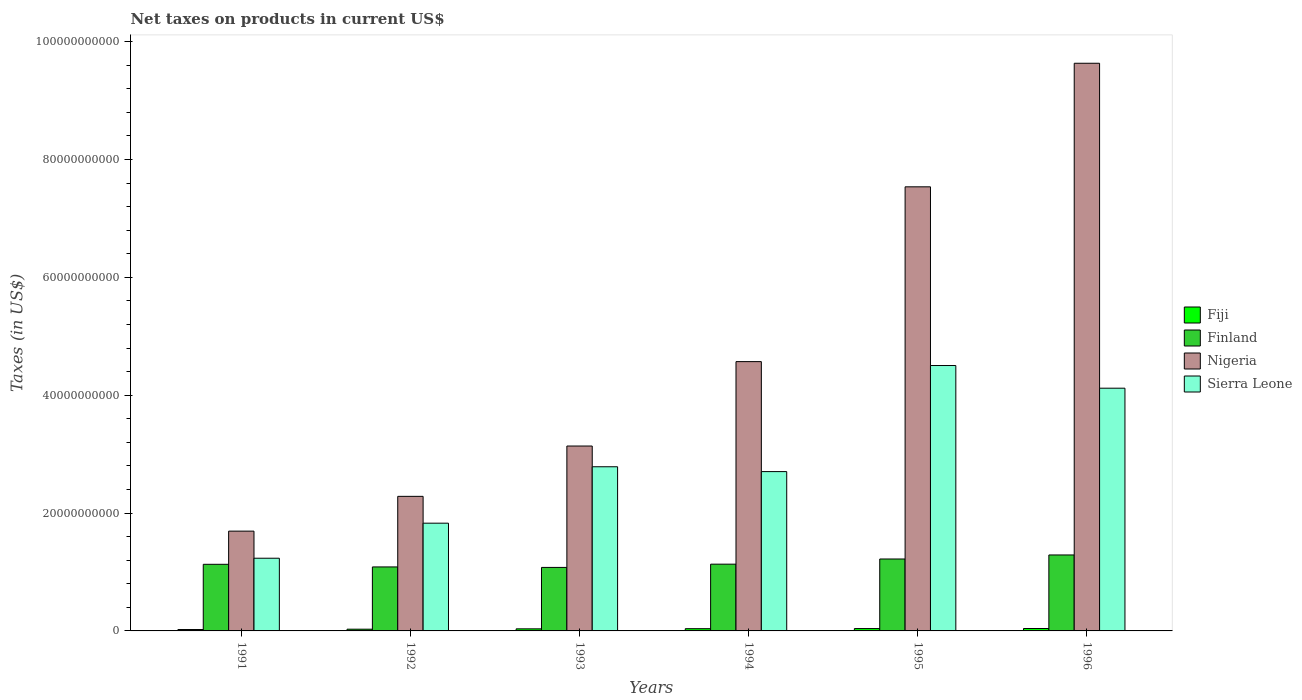Are the number of bars on each tick of the X-axis equal?
Your answer should be very brief. Yes. What is the net taxes on products in Nigeria in 1992?
Keep it short and to the point. 2.28e+1. Across all years, what is the maximum net taxes on products in Fiji?
Your answer should be compact. 4.10e+08. Across all years, what is the minimum net taxes on products in Fiji?
Your response must be concise. 2.37e+08. What is the total net taxes on products in Nigeria in the graph?
Your answer should be very brief. 2.88e+11. What is the difference between the net taxes on products in Nigeria in 1994 and that in 1995?
Offer a terse response. -2.97e+1. What is the difference between the net taxes on products in Nigeria in 1994 and the net taxes on products in Sierra Leone in 1995?
Provide a short and direct response. 6.62e+08. What is the average net taxes on products in Sierra Leone per year?
Keep it short and to the point. 2.86e+1. In the year 1992, what is the difference between the net taxes on products in Finland and net taxes on products in Sierra Leone?
Provide a succinct answer. -7.42e+09. What is the ratio of the net taxes on products in Fiji in 1991 to that in 1993?
Keep it short and to the point. 0.67. Is the difference between the net taxes on products in Finland in 1993 and 1994 greater than the difference between the net taxes on products in Sierra Leone in 1993 and 1994?
Offer a very short reply. No. What is the difference between the highest and the second highest net taxes on products in Finland?
Give a very brief answer. 6.85e+08. What is the difference between the highest and the lowest net taxes on products in Sierra Leone?
Provide a short and direct response. 3.27e+1. What does the 1st bar from the left in 1993 represents?
Keep it short and to the point. Fiji. What does the 3rd bar from the right in 1991 represents?
Offer a terse response. Finland. How many bars are there?
Provide a short and direct response. 24. How many years are there in the graph?
Provide a short and direct response. 6. Does the graph contain any zero values?
Provide a succinct answer. No. Does the graph contain grids?
Offer a very short reply. No. How many legend labels are there?
Provide a short and direct response. 4. How are the legend labels stacked?
Provide a succinct answer. Vertical. What is the title of the graph?
Offer a very short reply. Net taxes on products in current US$. What is the label or title of the Y-axis?
Keep it short and to the point. Taxes (in US$). What is the Taxes (in US$) in Fiji in 1991?
Your response must be concise. 2.37e+08. What is the Taxes (in US$) of Finland in 1991?
Offer a terse response. 1.13e+1. What is the Taxes (in US$) in Nigeria in 1991?
Your response must be concise. 1.69e+1. What is the Taxes (in US$) in Sierra Leone in 1991?
Provide a succinct answer. 1.23e+1. What is the Taxes (in US$) of Fiji in 1992?
Your answer should be very brief. 2.92e+08. What is the Taxes (in US$) in Finland in 1992?
Your response must be concise. 1.09e+1. What is the Taxes (in US$) in Nigeria in 1992?
Ensure brevity in your answer.  2.28e+1. What is the Taxes (in US$) of Sierra Leone in 1992?
Your answer should be very brief. 1.83e+1. What is the Taxes (in US$) of Fiji in 1993?
Your response must be concise. 3.52e+08. What is the Taxes (in US$) of Finland in 1993?
Ensure brevity in your answer.  1.08e+1. What is the Taxes (in US$) in Nigeria in 1993?
Offer a terse response. 3.14e+1. What is the Taxes (in US$) of Sierra Leone in 1993?
Offer a terse response. 2.79e+1. What is the Taxes (in US$) in Fiji in 1994?
Your answer should be very brief. 3.79e+08. What is the Taxes (in US$) in Finland in 1994?
Make the answer very short. 1.13e+1. What is the Taxes (in US$) of Nigeria in 1994?
Offer a terse response. 4.57e+1. What is the Taxes (in US$) in Sierra Leone in 1994?
Your response must be concise. 2.70e+1. What is the Taxes (in US$) in Fiji in 1995?
Your answer should be very brief. 3.98e+08. What is the Taxes (in US$) of Finland in 1995?
Your answer should be compact. 1.22e+1. What is the Taxes (in US$) of Nigeria in 1995?
Give a very brief answer. 7.54e+1. What is the Taxes (in US$) of Sierra Leone in 1995?
Give a very brief answer. 4.50e+1. What is the Taxes (in US$) in Fiji in 1996?
Give a very brief answer. 4.10e+08. What is the Taxes (in US$) of Finland in 1996?
Provide a succinct answer. 1.29e+1. What is the Taxes (in US$) of Nigeria in 1996?
Your answer should be very brief. 9.63e+1. What is the Taxes (in US$) of Sierra Leone in 1996?
Your answer should be compact. 4.12e+1. Across all years, what is the maximum Taxes (in US$) in Fiji?
Your answer should be compact. 4.10e+08. Across all years, what is the maximum Taxes (in US$) in Finland?
Provide a short and direct response. 1.29e+1. Across all years, what is the maximum Taxes (in US$) of Nigeria?
Make the answer very short. 9.63e+1. Across all years, what is the maximum Taxes (in US$) of Sierra Leone?
Ensure brevity in your answer.  4.50e+1. Across all years, what is the minimum Taxes (in US$) in Fiji?
Offer a very short reply. 2.37e+08. Across all years, what is the minimum Taxes (in US$) of Finland?
Provide a short and direct response. 1.08e+1. Across all years, what is the minimum Taxes (in US$) in Nigeria?
Ensure brevity in your answer.  1.69e+1. Across all years, what is the minimum Taxes (in US$) in Sierra Leone?
Offer a terse response. 1.23e+1. What is the total Taxes (in US$) of Fiji in the graph?
Give a very brief answer. 2.07e+09. What is the total Taxes (in US$) in Finland in the graph?
Provide a succinct answer. 6.94e+1. What is the total Taxes (in US$) of Nigeria in the graph?
Offer a very short reply. 2.88e+11. What is the total Taxes (in US$) of Sierra Leone in the graph?
Offer a very short reply. 1.72e+11. What is the difference between the Taxes (in US$) of Fiji in 1991 and that in 1992?
Your answer should be very brief. -5.58e+07. What is the difference between the Taxes (in US$) in Finland in 1991 and that in 1992?
Offer a very short reply. 4.46e+08. What is the difference between the Taxes (in US$) in Nigeria in 1991 and that in 1992?
Your response must be concise. -5.90e+09. What is the difference between the Taxes (in US$) of Sierra Leone in 1991 and that in 1992?
Provide a succinct answer. -5.95e+09. What is the difference between the Taxes (in US$) of Fiji in 1991 and that in 1993?
Your answer should be very brief. -1.16e+08. What is the difference between the Taxes (in US$) in Finland in 1991 and that in 1993?
Give a very brief answer. 5.28e+08. What is the difference between the Taxes (in US$) in Nigeria in 1991 and that in 1993?
Offer a very short reply. -1.44e+1. What is the difference between the Taxes (in US$) of Sierra Leone in 1991 and that in 1993?
Provide a succinct answer. -1.55e+1. What is the difference between the Taxes (in US$) in Fiji in 1991 and that in 1994?
Your response must be concise. -1.42e+08. What is the difference between the Taxes (in US$) of Finland in 1991 and that in 1994?
Your response must be concise. -2.30e+07. What is the difference between the Taxes (in US$) in Nigeria in 1991 and that in 1994?
Give a very brief answer. -2.88e+1. What is the difference between the Taxes (in US$) in Sierra Leone in 1991 and that in 1994?
Your answer should be compact. -1.47e+1. What is the difference between the Taxes (in US$) of Fiji in 1991 and that in 1995?
Make the answer very short. -1.61e+08. What is the difference between the Taxes (in US$) of Finland in 1991 and that in 1995?
Your answer should be compact. -9.01e+08. What is the difference between the Taxes (in US$) of Nigeria in 1991 and that in 1995?
Offer a very short reply. -5.84e+1. What is the difference between the Taxes (in US$) of Sierra Leone in 1991 and that in 1995?
Offer a very short reply. -3.27e+1. What is the difference between the Taxes (in US$) of Fiji in 1991 and that in 1996?
Give a very brief answer. -1.73e+08. What is the difference between the Taxes (in US$) in Finland in 1991 and that in 1996?
Your answer should be compact. -1.59e+09. What is the difference between the Taxes (in US$) of Nigeria in 1991 and that in 1996?
Make the answer very short. -7.94e+1. What is the difference between the Taxes (in US$) in Sierra Leone in 1991 and that in 1996?
Offer a terse response. -2.88e+1. What is the difference between the Taxes (in US$) of Fiji in 1992 and that in 1993?
Offer a very short reply. -5.97e+07. What is the difference between the Taxes (in US$) in Finland in 1992 and that in 1993?
Your answer should be very brief. 8.20e+07. What is the difference between the Taxes (in US$) of Nigeria in 1992 and that in 1993?
Offer a terse response. -8.54e+09. What is the difference between the Taxes (in US$) of Sierra Leone in 1992 and that in 1993?
Make the answer very short. -9.57e+09. What is the difference between the Taxes (in US$) in Fiji in 1992 and that in 1994?
Ensure brevity in your answer.  -8.65e+07. What is the difference between the Taxes (in US$) of Finland in 1992 and that in 1994?
Your answer should be compact. -4.69e+08. What is the difference between the Taxes (in US$) of Nigeria in 1992 and that in 1994?
Your answer should be compact. -2.29e+1. What is the difference between the Taxes (in US$) in Sierra Leone in 1992 and that in 1994?
Provide a succinct answer. -8.75e+09. What is the difference between the Taxes (in US$) in Fiji in 1992 and that in 1995?
Your response must be concise. -1.05e+08. What is the difference between the Taxes (in US$) in Finland in 1992 and that in 1995?
Provide a short and direct response. -1.35e+09. What is the difference between the Taxes (in US$) of Nigeria in 1992 and that in 1995?
Your answer should be compact. -5.25e+1. What is the difference between the Taxes (in US$) of Sierra Leone in 1992 and that in 1995?
Your response must be concise. -2.68e+1. What is the difference between the Taxes (in US$) in Fiji in 1992 and that in 1996?
Provide a succinct answer. -1.17e+08. What is the difference between the Taxes (in US$) of Finland in 1992 and that in 1996?
Your answer should be very brief. -2.03e+09. What is the difference between the Taxes (in US$) of Nigeria in 1992 and that in 1996?
Keep it short and to the point. -7.35e+1. What is the difference between the Taxes (in US$) of Sierra Leone in 1992 and that in 1996?
Your answer should be very brief. -2.29e+1. What is the difference between the Taxes (in US$) of Fiji in 1993 and that in 1994?
Your answer should be very brief. -2.68e+07. What is the difference between the Taxes (in US$) of Finland in 1993 and that in 1994?
Offer a terse response. -5.51e+08. What is the difference between the Taxes (in US$) of Nigeria in 1993 and that in 1994?
Give a very brief answer. -1.43e+1. What is the difference between the Taxes (in US$) of Sierra Leone in 1993 and that in 1994?
Give a very brief answer. 8.21e+08. What is the difference between the Taxes (in US$) in Fiji in 1993 and that in 1995?
Provide a short and direct response. -4.57e+07. What is the difference between the Taxes (in US$) of Finland in 1993 and that in 1995?
Provide a short and direct response. -1.43e+09. What is the difference between the Taxes (in US$) in Nigeria in 1993 and that in 1995?
Provide a succinct answer. -4.40e+1. What is the difference between the Taxes (in US$) in Sierra Leone in 1993 and that in 1995?
Make the answer very short. -1.72e+1. What is the difference between the Taxes (in US$) of Fiji in 1993 and that in 1996?
Your response must be concise. -5.74e+07. What is the difference between the Taxes (in US$) in Finland in 1993 and that in 1996?
Your answer should be compact. -2.11e+09. What is the difference between the Taxes (in US$) in Nigeria in 1993 and that in 1996?
Your answer should be very brief. -6.49e+1. What is the difference between the Taxes (in US$) in Sierra Leone in 1993 and that in 1996?
Your answer should be compact. -1.33e+1. What is the difference between the Taxes (in US$) of Fiji in 1994 and that in 1995?
Give a very brief answer. -1.89e+07. What is the difference between the Taxes (in US$) in Finland in 1994 and that in 1995?
Your response must be concise. -8.78e+08. What is the difference between the Taxes (in US$) of Nigeria in 1994 and that in 1995?
Keep it short and to the point. -2.97e+1. What is the difference between the Taxes (in US$) in Sierra Leone in 1994 and that in 1995?
Offer a very short reply. -1.80e+1. What is the difference between the Taxes (in US$) in Fiji in 1994 and that in 1996?
Provide a short and direct response. -3.06e+07. What is the difference between the Taxes (in US$) in Finland in 1994 and that in 1996?
Your response must be concise. -1.56e+09. What is the difference between the Taxes (in US$) of Nigeria in 1994 and that in 1996?
Your response must be concise. -5.06e+1. What is the difference between the Taxes (in US$) in Sierra Leone in 1994 and that in 1996?
Your answer should be very brief. -1.42e+1. What is the difference between the Taxes (in US$) in Fiji in 1995 and that in 1996?
Provide a short and direct response. -1.17e+07. What is the difference between the Taxes (in US$) of Finland in 1995 and that in 1996?
Your answer should be compact. -6.85e+08. What is the difference between the Taxes (in US$) in Nigeria in 1995 and that in 1996?
Offer a terse response. -2.10e+1. What is the difference between the Taxes (in US$) in Sierra Leone in 1995 and that in 1996?
Your answer should be compact. 3.85e+09. What is the difference between the Taxes (in US$) in Fiji in 1991 and the Taxes (in US$) in Finland in 1992?
Provide a short and direct response. -1.06e+1. What is the difference between the Taxes (in US$) in Fiji in 1991 and the Taxes (in US$) in Nigeria in 1992?
Give a very brief answer. -2.26e+1. What is the difference between the Taxes (in US$) of Fiji in 1991 and the Taxes (in US$) of Sierra Leone in 1992?
Provide a short and direct response. -1.80e+1. What is the difference between the Taxes (in US$) of Finland in 1991 and the Taxes (in US$) of Nigeria in 1992?
Make the answer very short. -1.15e+1. What is the difference between the Taxes (in US$) of Finland in 1991 and the Taxes (in US$) of Sierra Leone in 1992?
Offer a terse response. -6.98e+09. What is the difference between the Taxes (in US$) in Nigeria in 1991 and the Taxes (in US$) in Sierra Leone in 1992?
Make the answer very short. -1.35e+09. What is the difference between the Taxes (in US$) of Fiji in 1991 and the Taxes (in US$) of Finland in 1993?
Your answer should be compact. -1.05e+1. What is the difference between the Taxes (in US$) of Fiji in 1991 and the Taxes (in US$) of Nigeria in 1993?
Provide a succinct answer. -3.11e+1. What is the difference between the Taxes (in US$) in Fiji in 1991 and the Taxes (in US$) in Sierra Leone in 1993?
Your response must be concise. -2.76e+1. What is the difference between the Taxes (in US$) in Finland in 1991 and the Taxes (in US$) in Nigeria in 1993?
Provide a short and direct response. -2.01e+1. What is the difference between the Taxes (in US$) in Finland in 1991 and the Taxes (in US$) in Sierra Leone in 1993?
Give a very brief answer. -1.66e+1. What is the difference between the Taxes (in US$) of Nigeria in 1991 and the Taxes (in US$) of Sierra Leone in 1993?
Keep it short and to the point. -1.09e+1. What is the difference between the Taxes (in US$) in Fiji in 1991 and the Taxes (in US$) in Finland in 1994?
Make the answer very short. -1.11e+1. What is the difference between the Taxes (in US$) of Fiji in 1991 and the Taxes (in US$) of Nigeria in 1994?
Make the answer very short. -4.55e+1. What is the difference between the Taxes (in US$) in Fiji in 1991 and the Taxes (in US$) in Sierra Leone in 1994?
Your response must be concise. -2.68e+1. What is the difference between the Taxes (in US$) of Finland in 1991 and the Taxes (in US$) of Nigeria in 1994?
Your response must be concise. -3.44e+1. What is the difference between the Taxes (in US$) in Finland in 1991 and the Taxes (in US$) in Sierra Leone in 1994?
Provide a succinct answer. -1.57e+1. What is the difference between the Taxes (in US$) of Nigeria in 1991 and the Taxes (in US$) of Sierra Leone in 1994?
Make the answer very short. -1.01e+1. What is the difference between the Taxes (in US$) in Fiji in 1991 and the Taxes (in US$) in Finland in 1995?
Your response must be concise. -1.20e+1. What is the difference between the Taxes (in US$) in Fiji in 1991 and the Taxes (in US$) in Nigeria in 1995?
Keep it short and to the point. -7.51e+1. What is the difference between the Taxes (in US$) in Fiji in 1991 and the Taxes (in US$) in Sierra Leone in 1995?
Provide a short and direct response. -4.48e+1. What is the difference between the Taxes (in US$) of Finland in 1991 and the Taxes (in US$) of Nigeria in 1995?
Give a very brief answer. -6.40e+1. What is the difference between the Taxes (in US$) in Finland in 1991 and the Taxes (in US$) in Sierra Leone in 1995?
Offer a terse response. -3.37e+1. What is the difference between the Taxes (in US$) of Nigeria in 1991 and the Taxes (in US$) of Sierra Leone in 1995?
Make the answer very short. -2.81e+1. What is the difference between the Taxes (in US$) in Fiji in 1991 and the Taxes (in US$) in Finland in 1996?
Your response must be concise. -1.27e+1. What is the difference between the Taxes (in US$) in Fiji in 1991 and the Taxes (in US$) in Nigeria in 1996?
Keep it short and to the point. -9.61e+1. What is the difference between the Taxes (in US$) of Fiji in 1991 and the Taxes (in US$) of Sierra Leone in 1996?
Your answer should be compact. -4.09e+1. What is the difference between the Taxes (in US$) of Finland in 1991 and the Taxes (in US$) of Nigeria in 1996?
Offer a very short reply. -8.50e+1. What is the difference between the Taxes (in US$) of Finland in 1991 and the Taxes (in US$) of Sierra Leone in 1996?
Offer a terse response. -2.99e+1. What is the difference between the Taxes (in US$) in Nigeria in 1991 and the Taxes (in US$) in Sierra Leone in 1996?
Provide a succinct answer. -2.43e+1. What is the difference between the Taxes (in US$) in Fiji in 1992 and the Taxes (in US$) in Finland in 1993?
Ensure brevity in your answer.  -1.05e+1. What is the difference between the Taxes (in US$) in Fiji in 1992 and the Taxes (in US$) in Nigeria in 1993?
Offer a very short reply. -3.11e+1. What is the difference between the Taxes (in US$) of Fiji in 1992 and the Taxes (in US$) of Sierra Leone in 1993?
Give a very brief answer. -2.76e+1. What is the difference between the Taxes (in US$) in Finland in 1992 and the Taxes (in US$) in Nigeria in 1993?
Provide a short and direct response. -2.05e+1. What is the difference between the Taxes (in US$) in Finland in 1992 and the Taxes (in US$) in Sierra Leone in 1993?
Give a very brief answer. -1.70e+1. What is the difference between the Taxes (in US$) of Nigeria in 1992 and the Taxes (in US$) of Sierra Leone in 1993?
Your response must be concise. -5.02e+09. What is the difference between the Taxes (in US$) of Fiji in 1992 and the Taxes (in US$) of Finland in 1994?
Your answer should be very brief. -1.10e+1. What is the difference between the Taxes (in US$) in Fiji in 1992 and the Taxes (in US$) in Nigeria in 1994?
Your response must be concise. -4.54e+1. What is the difference between the Taxes (in US$) in Fiji in 1992 and the Taxes (in US$) in Sierra Leone in 1994?
Keep it short and to the point. -2.67e+1. What is the difference between the Taxes (in US$) in Finland in 1992 and the Taxes (in US$) in Nigeria in 1994?
Provide a short and direct response. -3.48e+1. What is the difference between the Taxes (in US$) of Finland in 1992 and the Taxes (in US$) of Sierra Leone in 1994?
Ensure brevity in your answer.  -1.62e+1. What is the difference between the Taxes (in US$) in Nigeria in 1992 and the Taxes (in US$) in Sierra Leone in 1994?
Offer a very short reply. -4.20e+09. What is the difference between the Taxes (in US$) of Fiji in 1992 and the Taxes (in US$) of Finland in 1995?
Your response must be concise. -1.19e+1. What is the difference between the Taxes (in US$) in Fiji in 1992 and the Taxes (in US$) in Nigeria in 1995?
Offer a very short reply. -7.51e+1. What is the difference between the Taxes (in US$) of Fiji in 1992 and the Taxes (in US$) of Sierra Leone in 1995?
Provide a succinct answer. -4.47e+1. What is the difference between the Taxes (in US$) of Finland in 1992 and the Taxes (in US$) of Nigeria in 1995?
Keep it short and to the point. -6.45e+1. What is the difference between the Taxes (in US$) of Finland in 1992 and the Taxes (in US$) of Sierra Leone in 1995?
Provide a short and direct response. -3.42e+1. What is the difference between the Taxes (in US$) in Nigeria in 1992 and the Taxes (in US$) in Sierra Leone in 1995?
Provide a short and direct response. -2.22e+1. What is the difference between the Taxes (in US$) in Fiji in 1992 and the Taxes (in US$) in Finland in 1996?
Give a very brief answer. -1.26e+1. What is the difference between the Taxes (in US$) of Fiji in 1992 and the Taxes (in US$) of Nigeria in 1996?
Offer a very short reply. -9.60e+1. What is the difference between the Taxes (in US$) in Fiji in 1992 and the Taxes (in US$) in Sierra Leone in 1996?
Give a very brief answer. -4.09e+1. What is the difference between the Taxes (in US$) in Finland in 1992 and the Taxes (in US$) in Nigeria in 1996?
Your answer should be very brief. -8.55e+1. What is the difference between the Taxes (in US$) in Finland in 1992 and the Taxes (in US$) in Sierra Leone in 1996?
Ensure brevity in your answer.  -3.03e+1. What is the difference between the Taxes (in US$) of Nigeria in 1992 and the Taxes (in US$) of Sierra Leone in 1996?
Keep it short and to the point. -1.84e+1. What is the difference between the Taxes (in US$) of Fiji in 1993 and the Taxes (in US$) of Finland in 1994?
Your answer should be very brief. -1.10e+1. What is the difference between the Taxes (in US$) of Fiji in 1993 and the Taxes (in US$) of Nigeria in 1994?
Offer a very short reply. -4.53e+1. What is the difference between the Taxes (in US$) of Fiji in 1993 and the Taxes (in US$) of Sierra Leone in 1994?
Provide a succinct answer. -2.67e+1. What is the difference between the Taxes (in US$) in Finland in 1993 and the Taxes (in US$) in Nigeria in 1994?
Keep it short and to the point. -3.49e+1. What is the difference between the Taxes (in US$) of Finland in 1993 and the Taxes (in US$) of Sierra Leone in 1994?
Provide a succinct answer. -1.63e+1. What is the difference between the Taxes (in US$) in Nigeria in 1993 and the Taxes (in US$) in Sierra Leone in 1994?
Offer a very short reply. 4.34e+09. What is the difference between the Taxes (in US$) of Fiji in 1993 and the Taxes (in US$) of Finland in 1995?
Ensure brevity in your answer.  -1.19e+1. What is the difference between the Taxes (in US$) in Fiji in 1993 and the Taxes (in US$) in Nigeria in 1995?
Your answer should be compact. -7.50e+1. What is the difference between the Taxes (in US$) of Fiji in 1993 and the Taxes (in US$) of Sierra Leone in 1995?
Your answer should be very brief. -4.47e+1. What is the difference between the Taxes (in US$) in Finland in 1993 and the Taxes (in US$) in Nigeria in 1995?
Offer a very short reply. -6.46e+1. What is the difference between the Taxes (in US$) of Finland in 1993 and the Taxes (in US$) of Sierra Leone in 1995?
Your response must be concise. -3.43e+1. What is the difference between the Taxes (in US$) in Nigeria in 1993 and the Taxes (in US$) in Sierra Leone in 1995?
Your response must be concise. -1.37e+1. What is the difference between the Taxes (in US$) in Fiji in 1993 and the Taxes (in US$) in Finland in 1996?
Keep it short and to the point. -1.25e+1. What is the difference between the Taxes (in US$) in Fiji in 1993 and the Taxes (in US$) in Nigeria in 1996?
Offer a terse response. -9.60e+1. What is the difference between the Taxes (in US$) in Fiji in 1993 and the Taxes (in US$) in Sierra Leone in 1996?
Your response must be concise. -4.08e+1. What is the difference between the Taxes (in US$) of Finland in 1993 and the Taxes (in US$) of Nigeria in 1996?
Keep it short and to the point. -8.55e+1. What is the difference between the Taxes (in US$) of Finland in 1993 and the Taxes (in US$) of Sierra Leone in 1996?
Your answer should be compact. -3.04e+1. What is the difference between the Taxes (in US$) in Nigeria in 1993 and the Taxes (in US$) in Sierra Leone in 1996?
Keep it short and to the point. -9.81e+09. What is the difference between the Taxes (in US$) of Fiji in 1994 and the Taxes (in US$) of Finland in 1995?
Offer a terse response. -1.18e+1. What is the difference between the Taxes (in US$) in Fiji in 1994 and the Taxes (in US$) in Nigeria in 1995?
Make the answer very short. -7.50e+1. What is the difference between the Taxes (in US$) in Fiji in 1994 and the Taxes (in US$) in Sierra Leone in 1995?
Give a very brief answer. -4.47e+1. What is the difference between the Taxes (in US$) in Finland in 1994 and the Taxes (in US$) in Nigeria in 1995?
Give a very brief answer. -6.40e+1. What is the difference between the Taxes (in US$) of Finland in 1994 and the Taxes (in US$) of Sierra Leone in 1995?
Your answer should be very brief. -3.37e+1. What is the difference between the Taxes (in US$) of Nigeria in 1994 and the Taxes (in US$) of Sierra Leone in 1995?
Your response must be concise. 6.62e+08. What is the difference between the Taxes (in US$) in Fiji in 1994 and the Taxes (in US$) in Finland in 1996?
Make the answer very short. -1.25e+1. What is the difference between the Taxes (in US$) in Fiji in 1994 and the Taxes (in US$) in Nigeria in 1996?
Offer a very short reply. -9.59e+1. What is the difference between the Taxes (in US$) in Fiji in 1994 and the Taxes (in US$) in Sierra Leone in 1996?
Your response must be concise. -4.08e+1. What is the difference between the Taxes (in US$) in Finland in 1994 and the Taxes (in US$) in Nigeria in 1996?
Give a very brief answer. -8.50e+1. What is the difference between the Taxes (in US$) in Finland in 1994 and the Taxes (in US$) in Sierra Leone in 1996?
Provide a short and direct response. -2.99e+1. What is the difference between the Taxes (in US$) in Nigeria in 1994 and the Taxes (in US$) in Sierra Leone in 1996?
Your answer should be very brief. 4.51e+09. What is the difference between the Taxes (in US$) of Fiji in 1995 and the Taxes (in US$) of Finland in 1996?
Offer a terse response. -1.25e+1. What is the difference between the Taxes (in US$) in Fiji in 1995 and the Taxes (in US$) in Nigeria in 1996?
Offer a very short reply. -9.59e+1. What is the difference between the Taxes (in US$) in Fiji in 1995 and the Taxes (in US$) in Sierra Leone in 1996?
Ensure brevity in your answer.  -4.08e+1. What is the difference between the Taxes (in US$) of Finland in 1995 and the Taxes (in US$) of Nigeria in 1996?
Keep it short and to the point. -8.41e+1. What is the difference between the Taxes (in US$) of Finland in 1995 and the Taxes (in US$) of Sierra Leone in 1996?
Your response must be concise. -2.90e+1. What is the difference between the Taxes (in US$) in Nigeria in 1995 and the Taxes (in US$) in Sierra Leone in 1996?
Keep it short and to the point. 3.42e+1. What is the average Taxes (in US$) in Fiji per year?
Offer a very short reply. 3.45e+08. What is the average Taxes (in US$) of Finland per year?
Keep it short and to the point. 1.16e+1. What is the average Taxes (in US$) of Nigeria per year?
Ensure brevity in your answer.  4.81e+1. What is the average Taxes (in US$) in Sierra Leone per year?
Offer a very short reply. 2.86e+1. In the year 1991, what is the difference between the Taxes (in US$) in Fiji and Taxes (in US$) in Finland?
Offer a very short reply. -1.11e+1. In the year 1991, what is the difference between the Taxes (in US$) of Fiji and Taxes (in US$) of Nigeria?
Your answer should be compact. -1.67e+1. In the year 1991, what is the difference between the Taxes (in US$) in Fiji and Taxes (in US$) in Sierra Leone?
Ensure brevity in your answer.  -1.21e+1. In the year 1991, what is the difference between the Taxes (in US$) of Finland and Taxes (in US$) of Nigeria?
Ensure brevity in your answer.  -5.63e+09. In the year 1991, what is the difference between the Taxes (in US$) of Finland and Taxes (in US$) of Sierra Leone?
Your answer should be compact. -1.03e+09. In the year 1991, what is the difference between the Taxes (in US$) in Nigeria and Taxes (in US$) in Sierra Leone?
Offer a very short reply. 4.60e+09. In the year 1992, what is the difference between the Taxes (in US$) in Fiji and Taxes (in US$) in Finland?
Offer a very short reply. -1.06e+1. In the year 1992, what is the difference between the Taxes (in US$) of Fiji and Taxes (in US$) of Nigeria?
Offer a terse response. -2.25e+1. In the year 1992, what is the difference between the Taxes (in US$) of Fiji and Taxes (in US$) of Sierra Leone?
Your answer should be very brief. -1.80e+1. In the year 1992, what is the difference between the Taxes (in US$) in Finland and Taxes (in US$) in Nigeria?
Provide a short and direct response. -1.20e+1. In the year 1992, what is the difference between the Taxes (in US$) in Finland and Taxes (in US$) in Sierra Leone?
Your answer should be very brief. -7.42e+09. In the year 1992, what is the difference between the Taxes (in US$) in Nigeria and Taxes (in US$) in Sierra Leone?
Make the answer very short. 4.55e+09. In the year 1993, what is the difference between the Taxes (in US$) in Fiji and Taxes (in US$) in Finland?
Make the answer very short. -1.04e+1. In the year 1993, what is the difference between the Taxes (in US$) of Fiji and Taxes (in US$) of Nigeria?
Your response must be concise. -3.10e+1. In the year 1993, what is the difference between the Taxes (in US$) in Fiji and Taxes (in US$) in Sierra Leone?
Your response must be concise. -2.75e+1. In the year 1993, what is the difference between the Taxes (in US$) of Finland and Taxes (in US$) of Nigeria?
Keep it short and to the point. -2.06e+1. In the year 1993, what is the difference between the Taxes (in US$) in Finland and Taxes (in US$) in Sierra Leone?
Provide a succinct answer. -1.71e+1. In the year 1993, what is the difference between the Taxes (in US$) of Nigeria and Taxes (in US$) of Sierra Leone?
Ensure brevity in your answer.  3.52e+09. In the year 1994, what is the difference between the Taxes (in US$) in Fiji and Taxes (in US$) in Finland?
Ensure brevity in your answer.  -1.09e+1. In the year 1994, what is the difference between the Taxes (in US$) of Fiji and Taxes (in US$) of Nigeria?
Offer a terse response. -4.53e+1. In the year 1994, what is the difference between the Taxes (in US$) of Fiji and Taxes (in US$) of Sierra Leone?
Keep it short and to the point. -2.67e+1. In the year 1994, what is the difference between the Taxes (in US$) in Finland and Taxes (in US$) in Nigeria?
Your response must be concise. -3.44e+1. In the year 1994, what is the difference between the Taxes (in US$) in Finland and Taxes (in US$) in Sierra Leone?
Provide a short and direct response. -1.57e+1. In the year 1994, what is the difference between the Taxes (in US$) of Nigeria and Taxes (in US$) of Sierra Leone?
Provide a short and direct response. 1.87e+1. In the year 1995, what is the difference between the Taxes (in US$) of Fiji and Taxes (in US$) of Finland?
Provide a succinct answer. -1.18e+1. In the year 1995, what is the difference between the Taxes (in US$) in Fiji and Taxes (in US$) in Nigeria?
Ensure brevity in your answer.  -7.50e+1. In the year 1995, what is the difference between the Taxes (in US$) of Fiji and Taxes (in US$) of Sierra Leone?
Offer a terse response. -4.46e+1. In the year 1995, what is the difference between the Taxes (in US$) in Finland and Taxes (in US$) in Nigeria?
Your answer should be compact. -6.31e+1. In the year 1995, what is the difference between the Taxes (in US$) of Finland and Taxes (in US$) of Sierra Leone?
Keep it short and to the point. -3.28e+1. In the year 1995, what is the difference between the Taxes (in US$) in Nigeria and Taxes (in US$) in Sierra Leone?
Your response must be concise. 3.03e+1. In the year 1996, what is the difference between the Taxes (in US$) in Fiji and Taxes (in US$) in Finland?
Your answer should be compact. -1.25e+1. In the year 1996, what is the difference between the Taxes (in US$) in Fiji and Taxes (in US$) in Nigeria?
Offer a terse response. -9.59e+1. In the year 1996, what is the difference between the Taxes (in US$) in Fiji and Taxes (in US$) in Sierra Leone?
Provide a short and direct response. -4.08e+1. In the year 1996, what is the difference between the Taxes (in US$) of Finland and Taxes (in US$) of Nigeria?
Your response must be concise. -8.34e+1. In the year 1996, what is the difference between the Taxes (in US$) of Finland and Taxes (in US$) of Sierra Leone?
Ensure brevity in your answer.  -2.83e+1. In the year 1996, what is the difference between the Taxes (in US$) in Nigeria and Taxes (in US$) in Sierra Leone?
Ensure brevity in your answer.  5.51e+1. What is the ratio of the Taxes (in US$) of Fiji in 1991 to that in 1992?
Offer a terse response. 0.81. What is the ratio of the Taxes (in US$) of Finland in 1991 to that in 1992?
Your response must be concise. 1.04. What is the ratio of the Taxes (in US$) of Nigeria in 1991 to that in 1992?
Offer a terse response. 0.74. What is the ratio of the Taxes (in US$) of Sierra Leone in 1991 to that in 1992?
Your answer should be very brief. 0.67. What is the ratio of the Taxes (in US$) of Fiji in 1991 to that in 1993?
Provide a short and direct response. 0.67. What is the ratio of the Taxes (in US$) of Finland in 1991 to that in 1993?
Provide a short and direct response. 1.05. What is the ratio of the Taxes (in US$) of Nigeria in 1991 to that in 1993?
Make the answer very short. 0.54. What is the ratio of the Taxes (in US$) in Sierra Leone in 1991 to that in 1993?
Your answer should be very brief. 0.44. What is the ratio of the Taxes (in US$) of Fiji in 1991 to that in 1994?
Keep it short and to the point. 0.62. What is the ratio of the Taxes (in US$) in Nigeria in 1991 to that in 1994?
Provide a short and direct response. 0.37. What is the ratio of the Taxes (in US$) of Sierra Leone in 1991 to that in 1994?
Keep it short and to the point. 0.46. What is the ratio of the Taxes (in US$) in Fiji in 1991 to that in 1995?
Make the answer very short. 0.59. What is the ratio of the Taxes (in US$) in Finland in 1991 to that in 1995?
Provide a short and direct response. 0.93. What is the ratio of the Taxes (in US$) of Nigeria in 1991 to that in 1995?
Give a very brief answer. 0.22. What is the ratio of the Taxes (in US$) in Sierra Leone in 1991 to that in 1995?
Your answer should be compact. 0.27. What is the ratio of the Taxes (in US$) of Fiji in 1991 to that in 1996?
Offer a very short reply. 0.58. What is the ratio of the Taxes (in US$) of Finland in 1991 to that in 1996?
Your answer should be compact. 0.88. What is the ratio of the Taxes (in US$) of Nigeria in 1991 to that in 1996?
Ensure brevity in your answer.  0.18. What is the ratio of the Taxes (in US$) in Sierra Leone in 1991 to that in 1996?
Your answer should be compact. 0.3. What is the ratio of the Taxes (in US$) of Fiji in 1992 to that in 1993?
Make the answer very short. 0.83. What is the ratio of the Taxes (in US$) in Finland in 1992 to that in 1993?
Your answer should be very brief. 1.01. What is the ratio of the Taxes (in US$) of Nigeria in 1992 to that in 1993?
Keep it short and to the point. 0.73. What is the ratio of the Taxes (in US$) in Sierra Leone in 1992 to that in 1993?
Your answer should be very brief. 0.66. What is the ratio of the Taxes (in US$) in Fiji in 1992 to that in 1994?
Ensure brevity in your answer.  0.77. What is the ratio of the Taxes (in US$) of Finland in 1992 to that in 1994?
Give a very brief answer. 0.96. What is the ratio of the Taxes (in US$) in Nigeria in 1992 to that in 1994?
Keep it short and to the point. 0.5. What is the ratio of the Taxes (in US$) of Sierra Leone in 1992 to that in 1994?
Offer a very short reply. 0.68. What is the ratio of the Taxes (in US$) of Fiji in 1992 to that in 1995?
Your answer should be compact. 0.74. What is the ratio of the Taxes (in US$) in Finland in 1992 to that in 1995?
Ensure brevity in your answer.  0.89. What is the ratio of the Taxes (in US$) in Nigeria in 1992 to that in 1995?
Give a very brief answer. 0.3. What is the ratio of the Taxes (in US$) in Sierra Leone in 1992 to that in 1995?
Keep it short and to the point. 0.41. What is the ratio of the Taxes (in US$) of Fiji in 1992 to that in 1996?
Give a very brief answer. 0.71. What is the ratio of the Taxes (in US$) of Finland in 1992 to that in 1996?
Keep it short and to the point. 0.84. What is the ratio of the Taxes (in US$) of Nigeria in 1992 to that in 1996?
Provide a succinct answer. 0.24. What is the ratio of the Taxes (in US$) of Sierra Leone in 1992 to that in 1996?
Offer a terse response. 0.44. What is the ratio of the Taxes (in US$) in Fiji in 1993 to that in 1994?
Make the answer very short. 0.93. What is the ratio of the Taxes (in US$) of Finland in 1993 to that in 1994?
Your answer should be compact. 0.95. What is the ratio of the Taxes (in US$) of Nigeria in 1993 to that in 1994?
Give a very brief answer. 0.69. What is the ratio of the Taxes (in US$) in Sierra Leone in 1993 to that in 1994?
Provide a succinct answer. 1.03. What is the ratio of the Taxes (in US$) in Fiji in 1993 to that in 1995?
Provide a succinct answer. 0.89. What is the ratio of the Taxes (in US$) in Finland in 1993 to that in 1995?
Provide a succinct answer. 0.88. What is the ratio of the Taxes (in US$) of Nigeria in 1993 to that in 1995?
Your answer should be compact. 0.42. What is the ratio of the Taxes (in US$) in Sierra Leone in 1993 to that in 1995?
Offer a terse response. 0.62. What is the ratio of the Taxes (in US$) in Fiji in 1993 to that in 1996?
Offer a very short reply. 0.86. What is the ratio of the Taxes (in US$) in Finland in 1993 to that in 1996?
Ensure brevity in your answer.  0.84. What is the ratio of the Taxes (in US$) in Nigeria in 1993 to that in 1996?
Keep it short and to the point. 0.33. What is the ratio of the Taxes (in US$) in Sierra Leone in 1993 to that in 1996?
Your response must be concise. 0.68. What is the ratio of the Taxes (in US$) of Fiji in 1994 to that in 1995?
Offer a terse response. 0.95. What is the ratio of the Taxes (in US$) of Finland in 1994 to that in 1995?
Provide a short and direct response. 0.93. What is the ratio of the Taxes (in US$) in Nigeria in 1994 to that in 1995?
Offer a terse response. 0.61. What is the ratio of the Taxes (in US$) in Sierra Leone in 1994 to that in 1995?
Your response must be concise. 0.6. What is the ratio of the Taxes (in US$) in Fiji in 1994 to that in 1996?
Provide a succinct answer. 0.93. What is the ratio of the Taxes (in US$) of Finland in 1994 to that in 1996?
Offer a terse response. 0.88. What is the ratio of the Taxes (in US$) of Nigeria in 1994 to that in 1996?
Offer a very short reply. 0.47. What is the ratio of the Taxes (in US$) in Sierra Leone in 1994 to that in 1996?
Offer a very short reply. 0.66. What is the ratio of the Taxes (in US$) of Fiji in 1995 to that in 1996?
Your answer should be compact. 0.97. What is the ratio of the Taxes (in US$) of Finland in 1995 to that in 1996?
Your answer should be very brief. 0.95. What is the ratio of the Taxes (in US$) in Nigeria in 1995 to that in 1996?
Make the answer very short. 0.78. What is the ratio of the Taxes (in US$) of Sierra Leone in 1995 to that in 1996?
Give a very brief answer. 1.09. What is the difference between the highest and the second highest Taxes (in US$) of Fiji?
Offer a very short reply. 1.17e+07. What is the difference between the highest and the second highest Taxes (in US$) of Finland?
Give a very brief answer. 6.85e+08. What is the difference between the highest and the second highest Taxes (in US$) in Nigeria?
Offer a very short reply. 2.10e+1. What is the difference between the highest and the second highest Taxes (in US$) of Sierra Leone?
Offer a terse response. 3.85e+09. What is the difference between the highest and the lowest Taxes (in US$) in Fiji?
Provide a short and direct response. 1.73e+08. What is the difference between the highest and the lowest Taxes (in US$) in Finland?
Your answer should be very brief. 2.11e+09. What is the difference between the highest and the lowest Taxes (in US$) of Nigeria?
Keep it short and to the point. 7.94e+1. What is the difference between the highest and the lowest Taxes (in US$) of Sierra Leone?
Your answer should be very brief. 3.27e+1. 